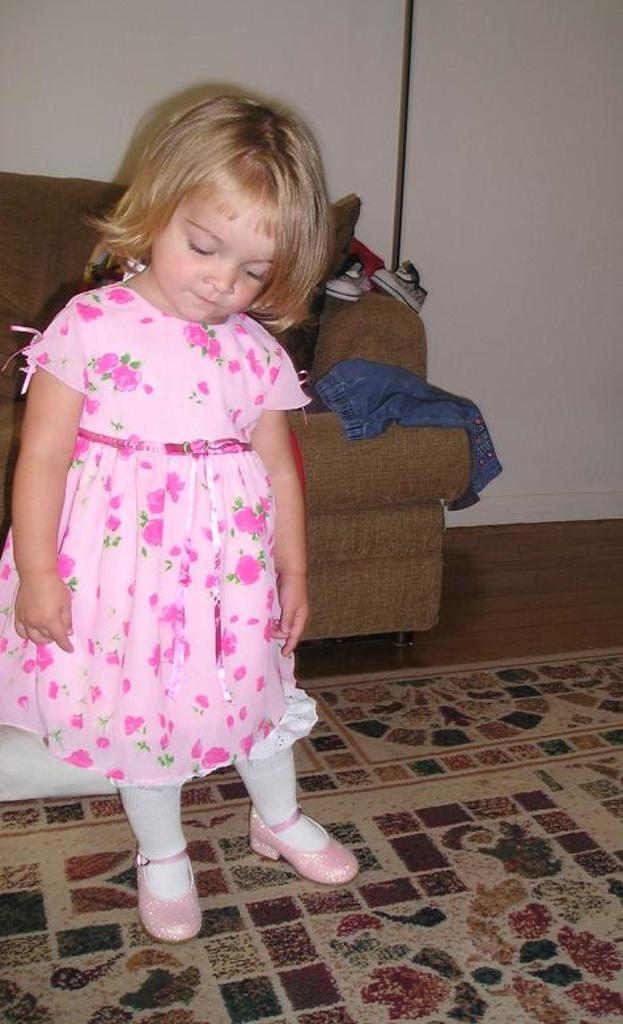What is the child doing in the image? The child is standing on the floor in the image. What can be seen in the background of the image? There is a sofa, jeans and shoes, a pole, and a wall visible in the background of the image. What type of watch is the child wearing in the image? There is no watch visible on the child in the image. 